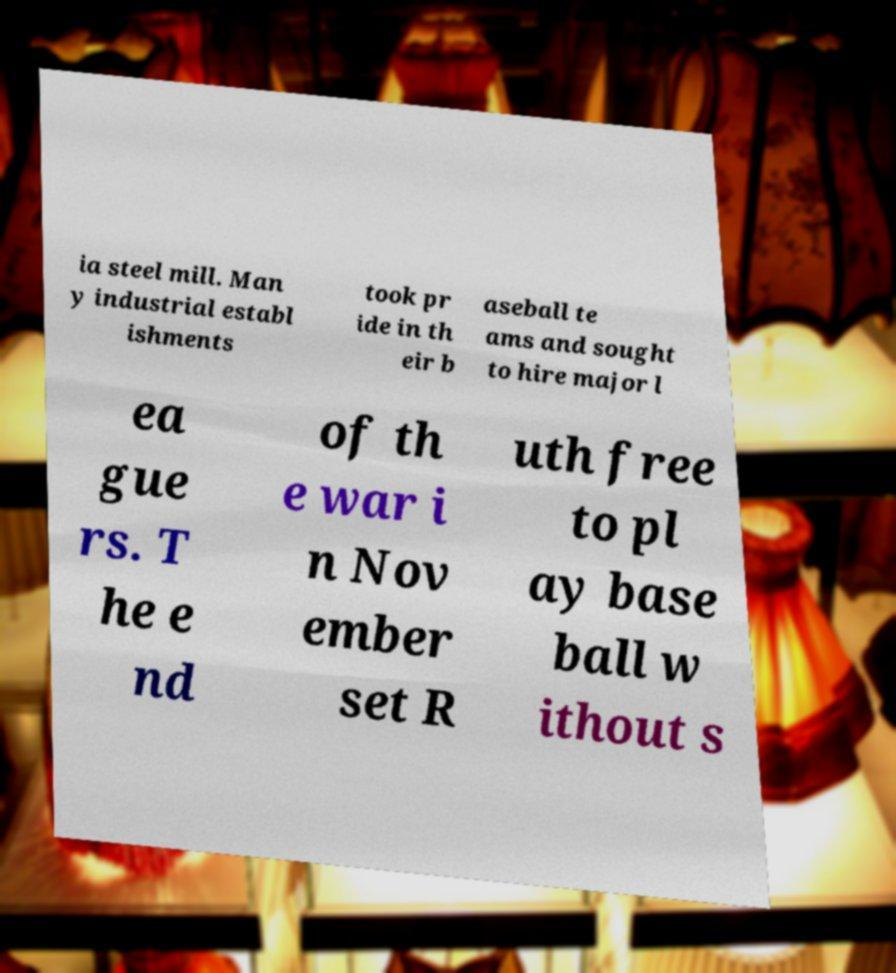Could you extract and type out the text from this image? ia steel mill. Man y industrial establ ishments took pr ide in th eir b aseball te ams and sought to hire major l ea gue rs. T he e nd of th e war i n Nov ember set R uth free to pl ay base ball w ithout s 